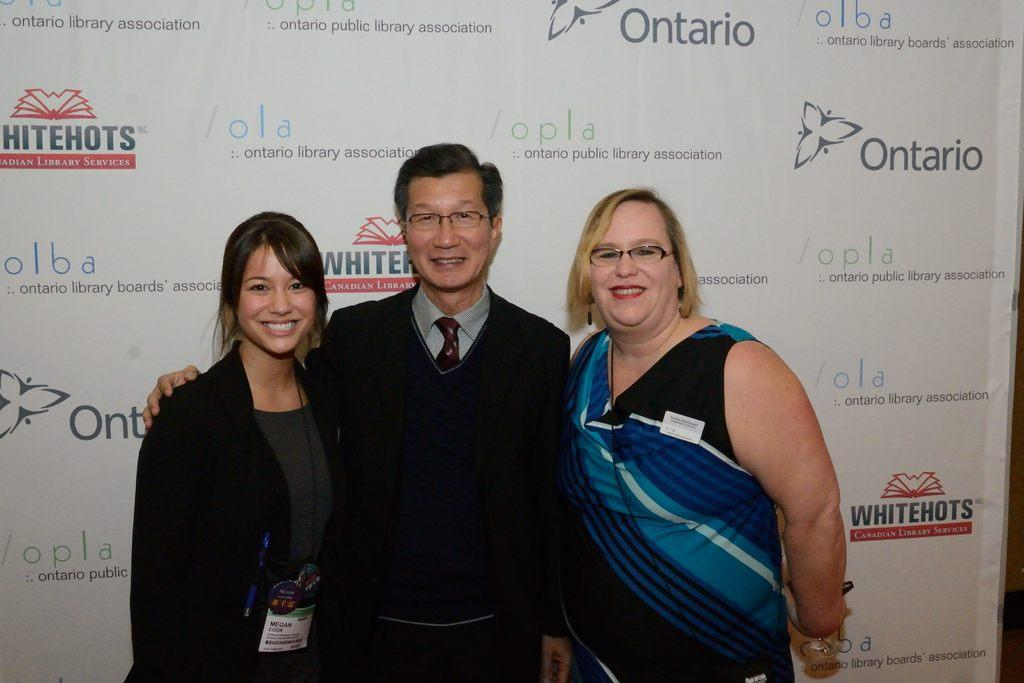<image>
Relay a brief, clear account of the picture shown. the word ontario that is on a sign 